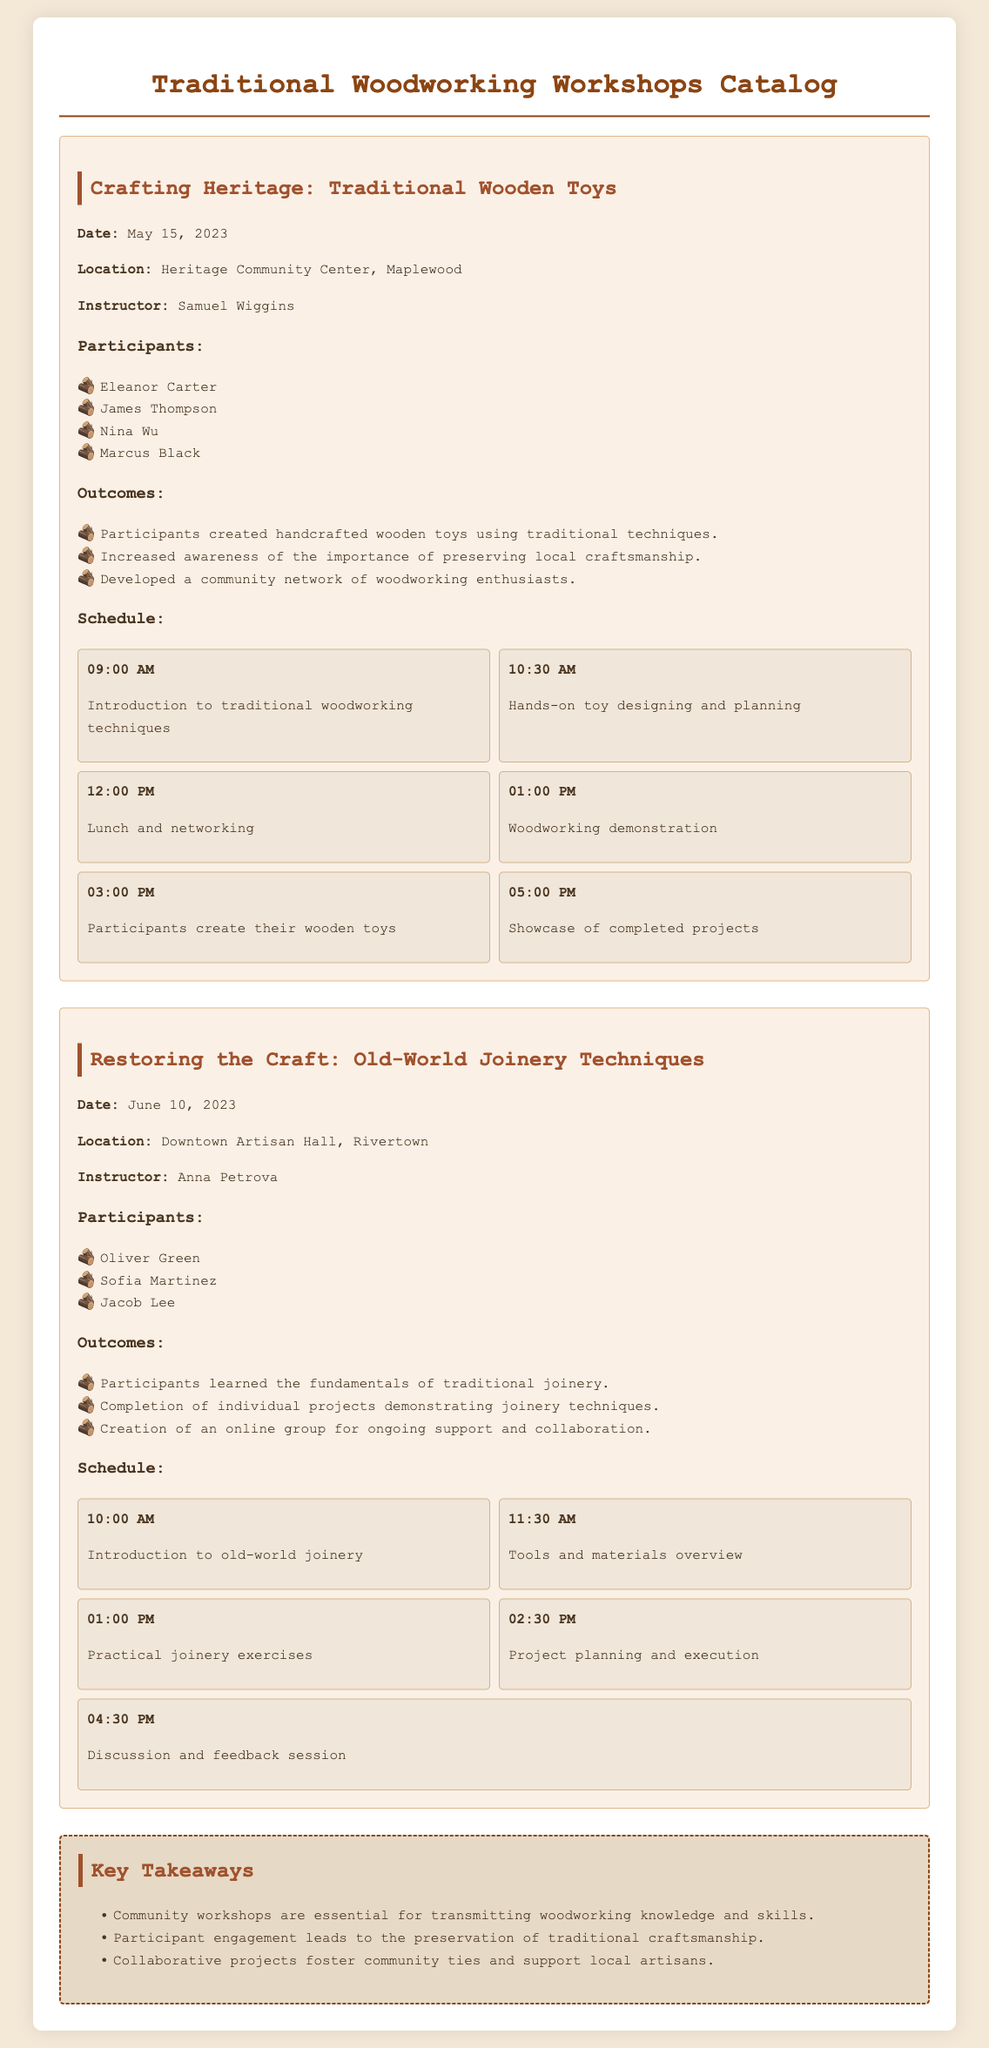What is the title of the first workshop? The first workshop is titled "Crafting Heritage: Traditional Wooden Toys."
Answer: Crafting Heritage: Traditional Wooden Toys Who was the instructor for the second workshop? The instructor for the second workshop is Anna Petrova.
Answer: Anna Petrova What date was the workshop about old-world joinery techniques held? The workshop on old-world joinery techniques was held on June 10, 2023.
Answer: June 10, 2023 How many participants were involved in the first workshop? There were four participants listed in the first workshop.
Answer: 4 What key takeaway highlights the importance of community workshops? One key takeaway states that community workshops are essential for transmitting woodworking knowledge and skills.
Answer: Transmitting woodworking knowledge and skills What was the first scheduled item for the second workshop? The first scheduled item for the second workshop was "Introduction to old-world joinery."
Answer: Introduction to old-world joinery What location hosted the workshop focused on traditional wooden toys? The workshop focused on traditional wooden toys was hosted at the Heritage Community Center, Maplewood.
Answer: Heritage Community Center, Maplewood Which participant created handcrafted wooden toys? Eleanor Carter created handcrafted wooden toys in the first workshop.
Answer: Eleanor Carter 